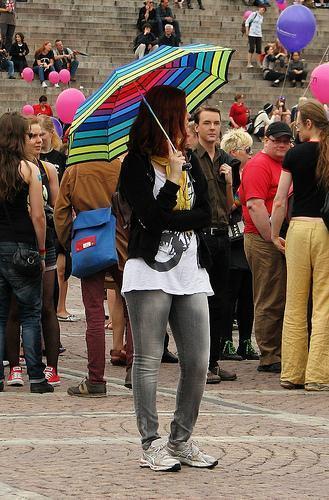How many people are under the umbrella?
Give a very brief answer. 1. 